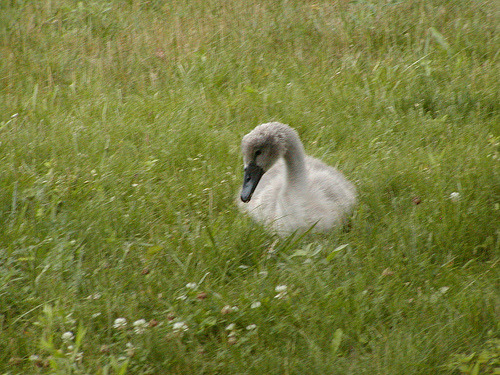<image>
Can you confirm if the goose is on the grass? Yes. Looking at the image, I can see the goose is positioned on top of the grass, with the grass providing support. Where is the duck in relation to the grass? Is it above the grass? No. The duck is not positioned above the grass. The vertical arrangement shows a different relationship. 